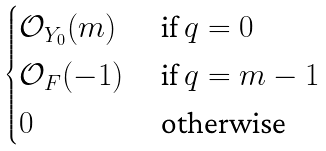<formula> <loc_0><loc_0><loc_500><loc_500>\begin{cases} \mathcal { O } _ { Y _ { 0 } } ( m ) & \text { if } q = 0 \\ \mathcal { O } _ { F } ( - 1 ) & \text { if } q = m - 1 \\ 0 & \text { otherwise} \end{cases}</formula> 